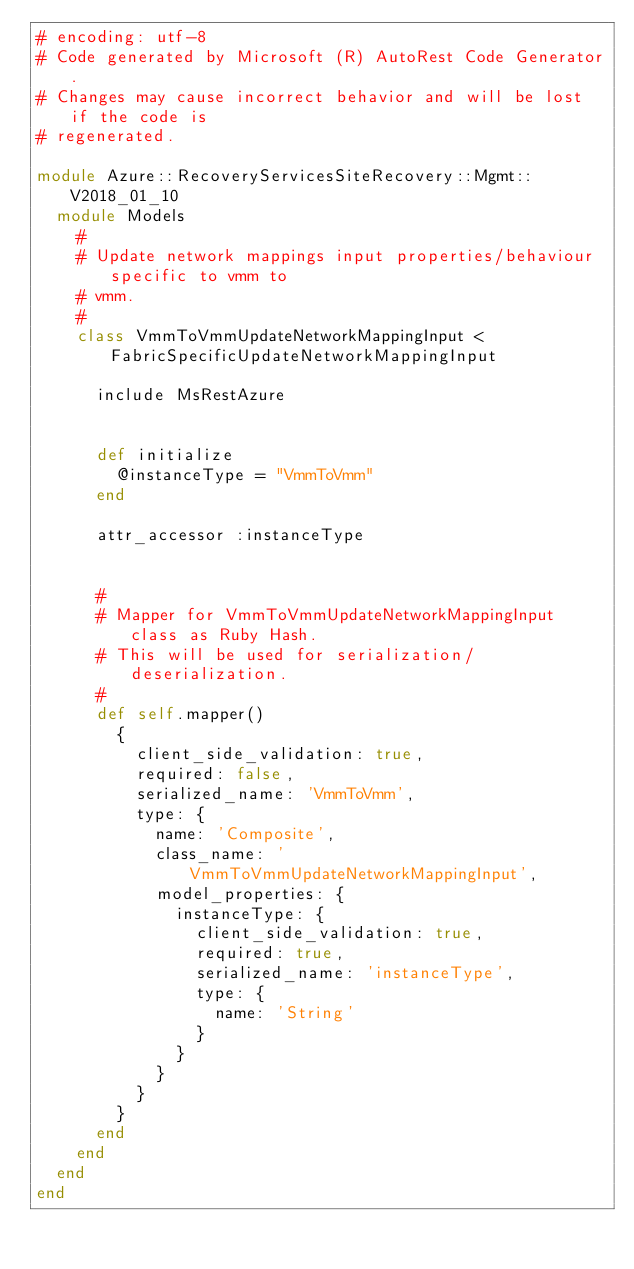Convert code to text. <code><loc_0><loc_0><loc_500><loc_500><_Ruby_># encoding: utf-8
# Code generated by Microsoft (R) AutoRest Code Generator.
# Changes may cause incorrect behavior and will be lost if the code is
# regenerated.

module Azure::RecoveryServicesSiteRecovery::Mgmt::V2018_01_10
  module Models
    #
    # Update network mappings input properties/behaviour specific to vmm to
    # vmm.
    #
    class VmmToVmmUpdateNetworkMappingInput < FabricSpecificUpdateNetworkMappingInput

      include MsRestAzure


      def initialize
        @instanceType = "VmmToVmm"
      end

      attr_accessor :instanceType


      #
      # Mapper for VmmToVmmUpdateNetworkMappingInput class as Ruby Hash.
      # This will be used for serialization/deserialization.
      #
      def self.mapper()
        {
          client_side_validation: true,
          required: false,
          serialized_name: 'VmmToVmm',
          type: {
            name: 'Composite',
            class_name: 'VmmToVmmUpdateNetworkMappingInput',
            model_properties: {
              instanceType: {
                client_side_validation: true,
                required: true,
                serialized_name: 'instanceType',
                type: {
                  name: 'String'
                }
              }
            }
          }
        }
      end
    end
  end
end
</code> 